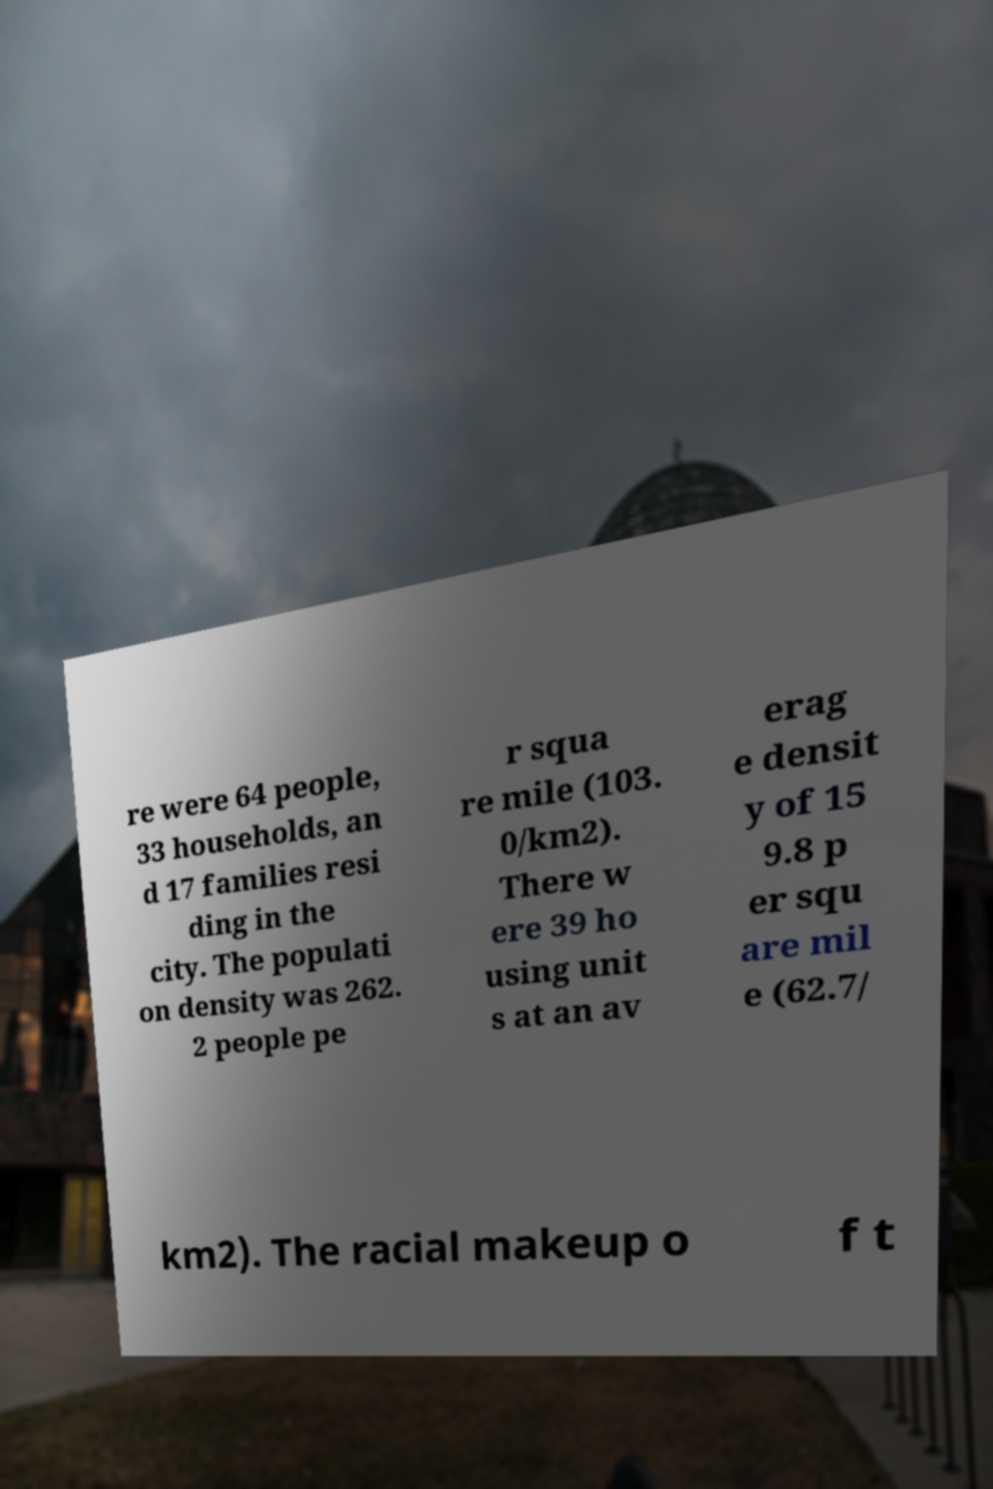Please identify and transcribe the text found in this image. re were 64 people, 33 households, an d 17 families resi ding in the city. The populati on density was 262. 2 people pe r squa re mile (103. 0/km2). There w ere 39 ho using unit s at an av erag e densit y of 15 9.8 p er squ are mil e (62.7/ km2). The racial makeup o f t 